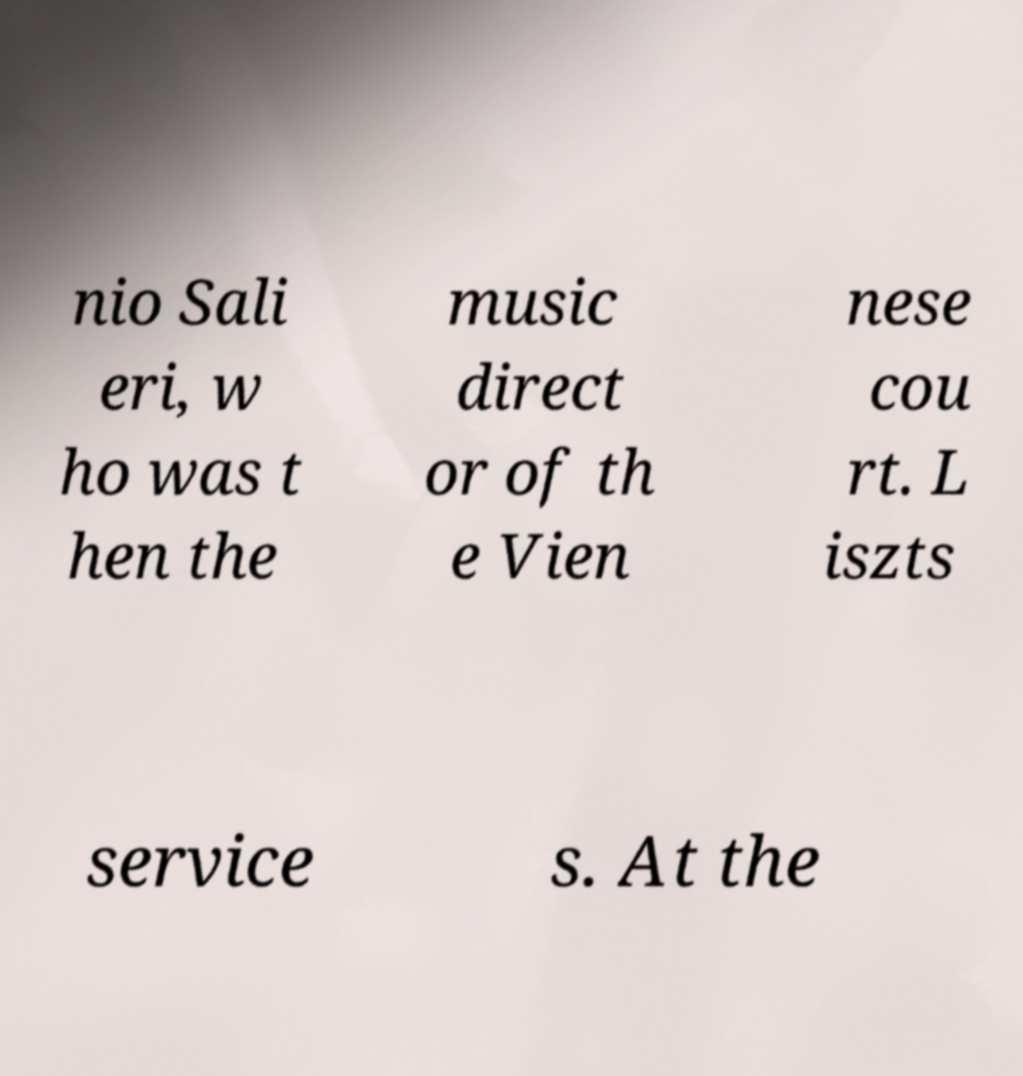Please identify and transcribe the text found in this image. nio Sali eri, w ho was t hen the music direct or of th e Vien nese cou rt. L iszts service s. At the 